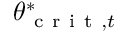<formula> <loc_0><loc_0><loc_500><loc_500>\theta _ { c r i t , t } ^ { * }</formula> 